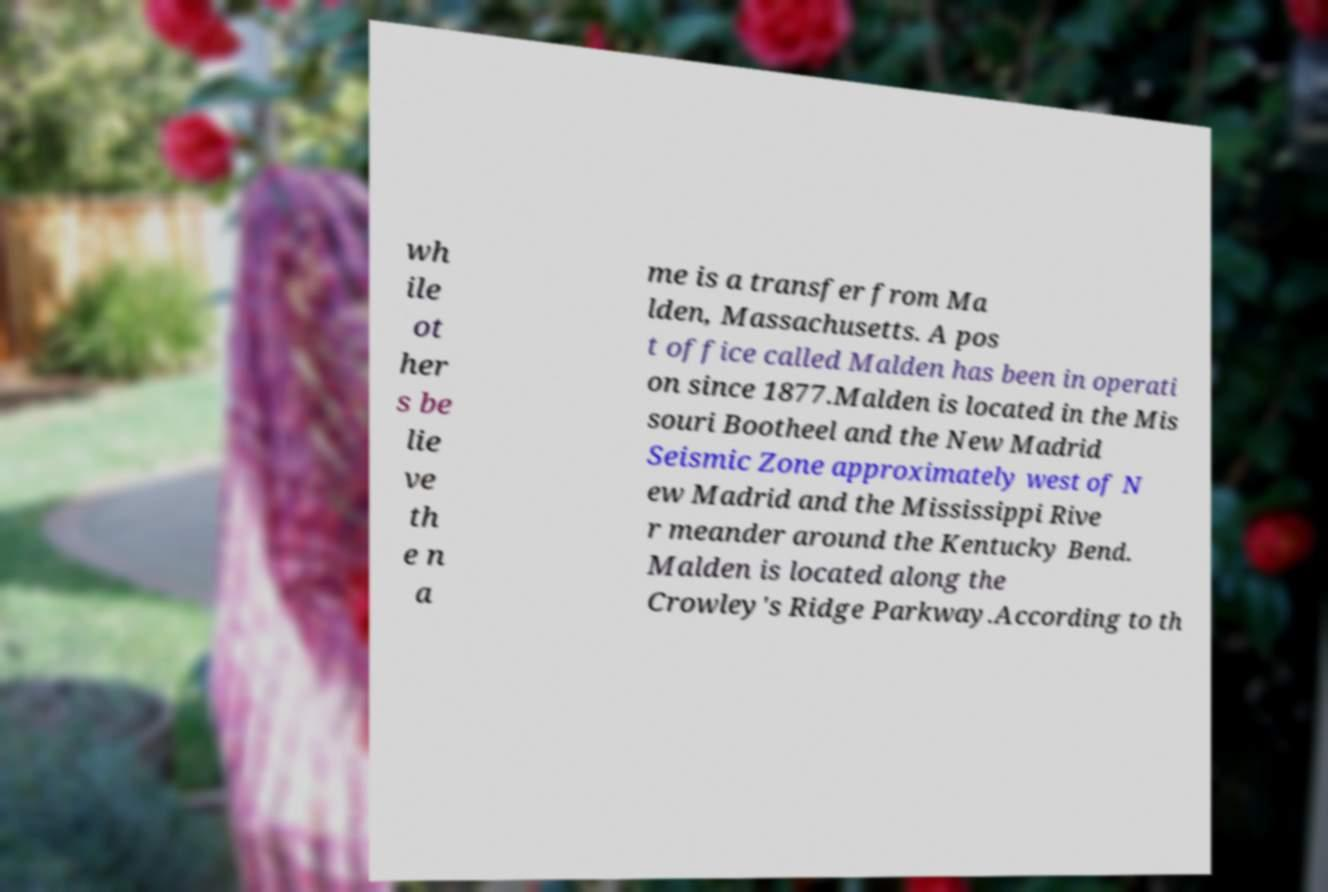Could you assist in decoding the text presented in this image and type it out clearly? wh ile ot her s be lie ve th e n a me is a transfer from Ma lden, Massachusetts. A pos t office called Malden has been in operati on since 1877.Malden is located in the Mis souri Bootheel and the New Madrid Seismic Zone approximately west of N ew Madrid and the Mississippi Rive r meander around the Kentucky Bend. Malden is located along the Crowley's Ridge Parkway.According to th 